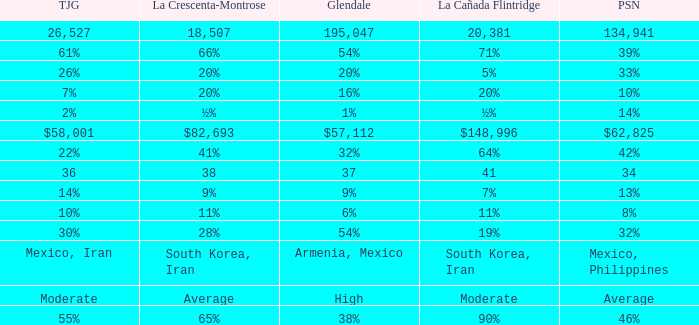When La Crescenta-Montrose has 66%, what is Tujunga? 61%. Could you help me parse every detail presented in this table? {'header': ['TJG', 'La Crescenta-Montrose', 'Glendale', 'La Cañada Flintridge', 'PSN'], 'rows': [['26,527', '18,507', '195,047', '20,381', '134,941'], ['61%', '66%', '54%', '71%', '39%'], ['26%', '20%', '20%', '5%', '33%'], ['7%', '20%', '16%', '20%', '10%'], ['2%', '½%', '1%', '½%', '14%'], ['$58,001', '$82,693', '$57,112', '$148,996', '$62,825'], ['22%', '41%', '32%', '64%', '42%'], ['36', '38', '37', '41', '34'], ['14%', '9%', '9%', '7%', '13%'], ['10%', '11%', '6%', '11%', '8%'], ['30%', '28%', '54%', '19%', '32%'], ['Mexico, Iran', 'South Korea, Iran', 'Armenia, Mexico', 'South Korea, Iran', 'Mexico, Philippines'], ['Moderate', 'Average', 'High', 'Moderate', 'Average'], ['55%', '65%', '38%', '90%', '46%']]} 